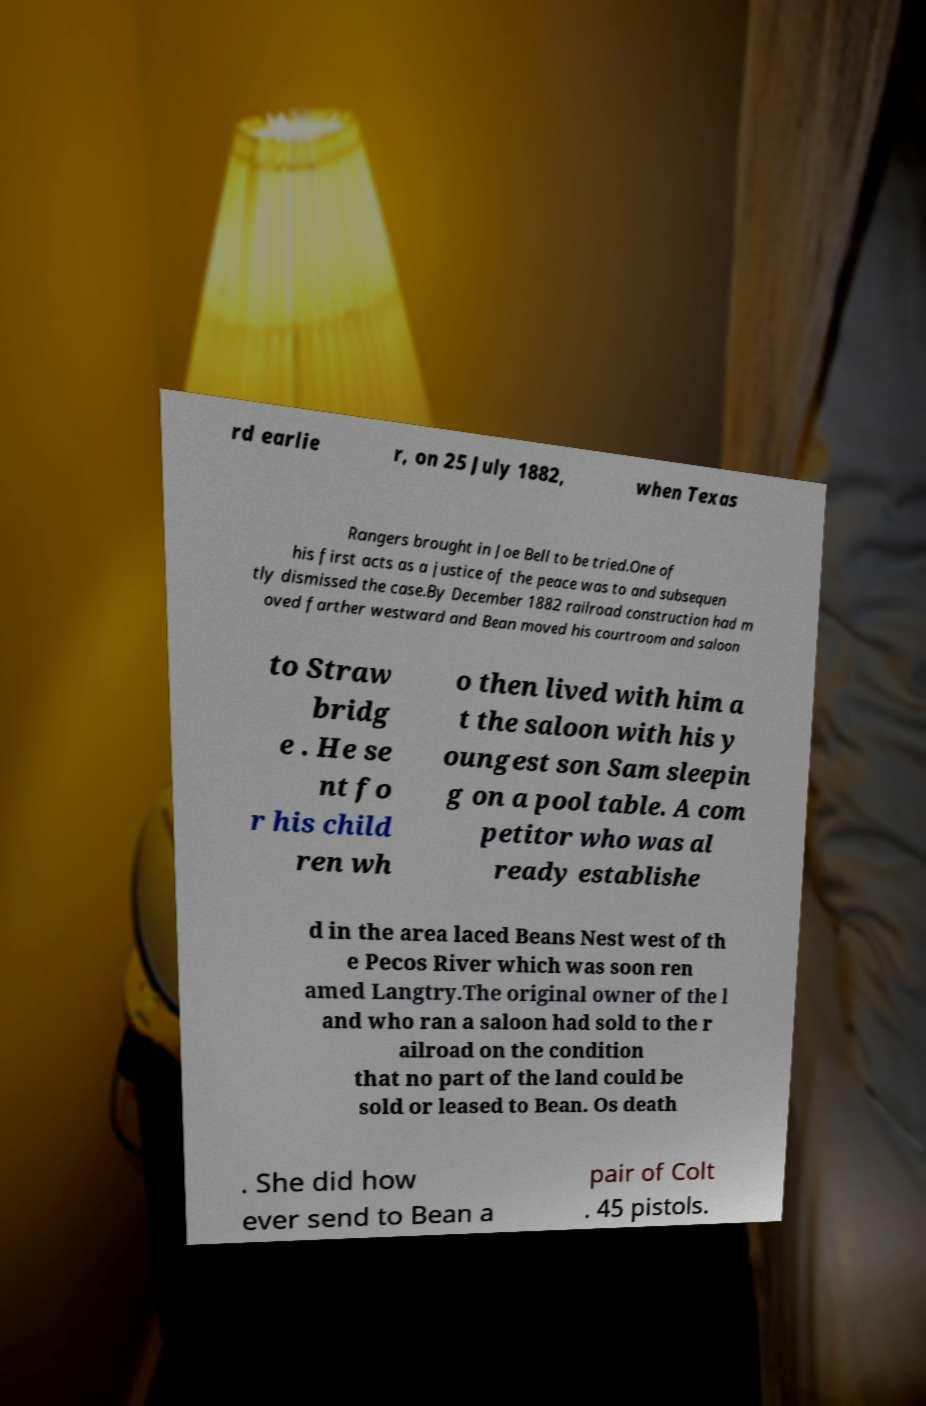Can you accurately transcribe the text from the provided image for me? rd earlie r, on 25 July 1882, when Texas Rangers brought in Joe Bell to be tried.One of his first acts as a justice of the peace was to and subsequen tly dismissed the case.By December 1882 railroad construction had m oved farther westward and Bean moved his courtroom and saloon to Straw bridg e . He se nt fo r his child ren wh o then lived with him a t the saloon with his y oungest son Sam sleepin g on a pool table. A com petitor who was al ready establishe d in the area laced Beans Nest west of th e Pecos River which was soon ren amed Langtry.The original owner of the l and who ran a saloon had sold to the r ailroad on the condition that no part of the land could be sold or leased to Bean. Os death . She did how ever send to Bean a pair of Colt . 45 pistols. 